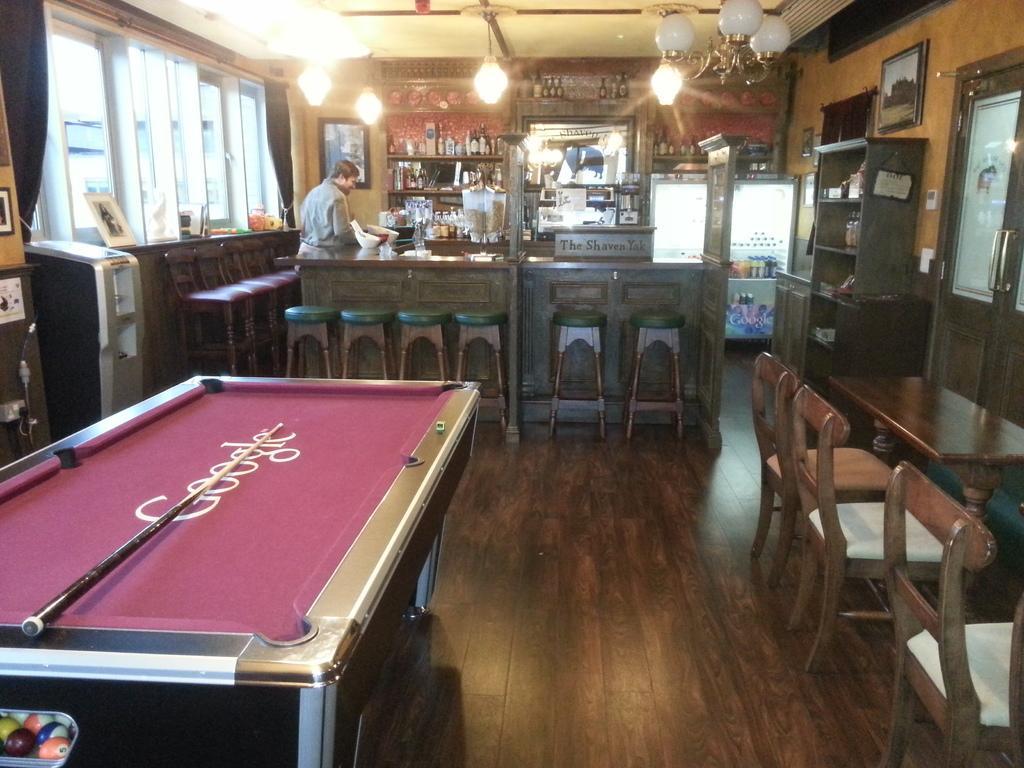How would you summarize this image in a sentence or two? As we can see in the image there are lights, window, tables, chairs and a man standing over here. 